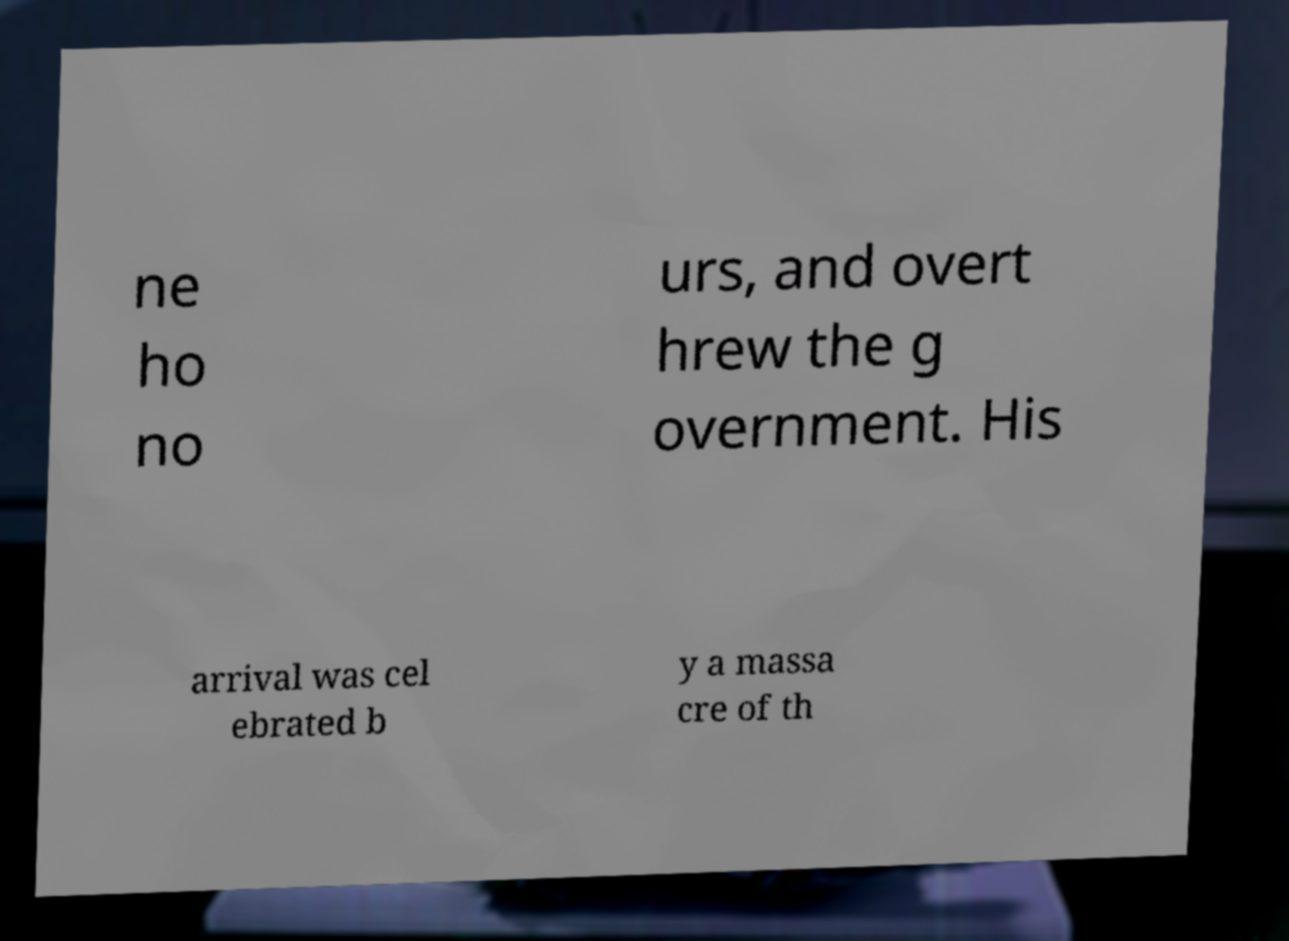What messages or text are displayed in this image? I need them in a readable, typed format. ne ho no urs, and overt hrew the g overnment. His arrival was cel ebrated b y a massa cre of th 